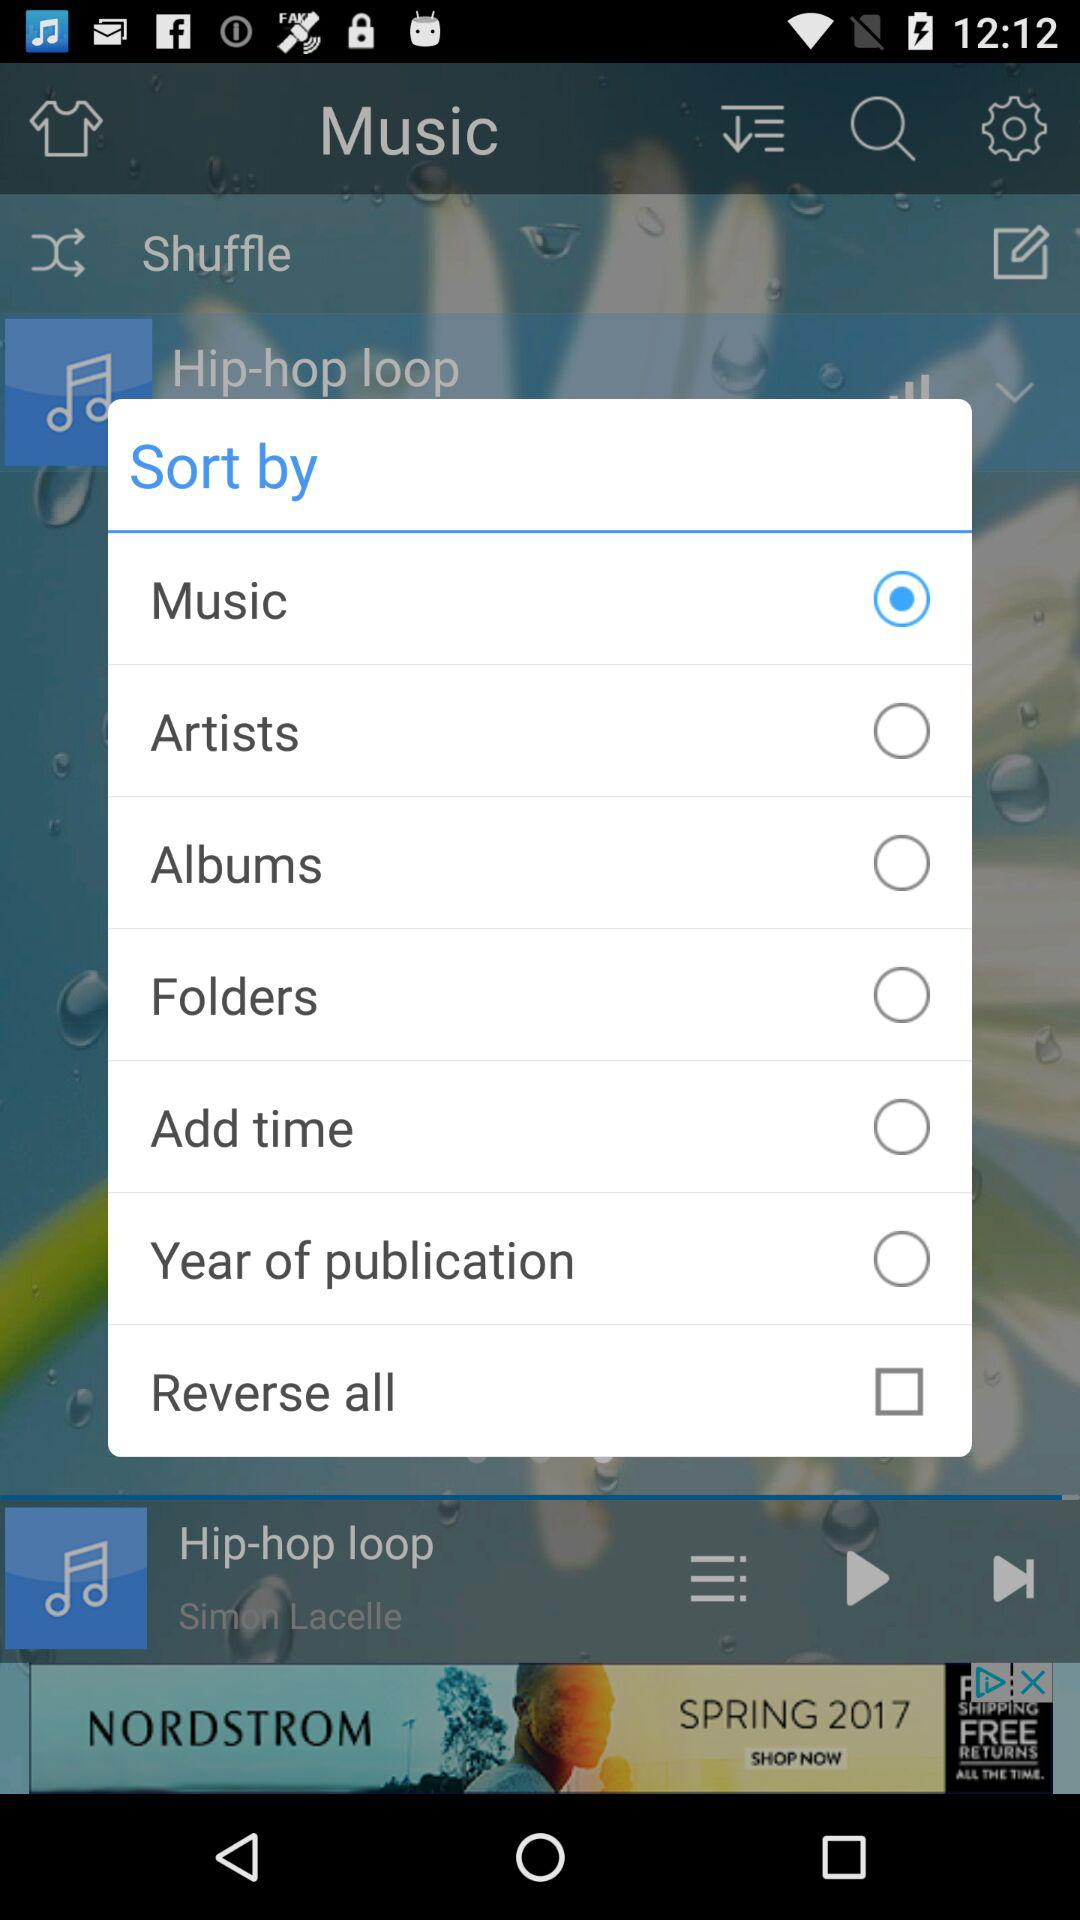What options are there for sorting the list? The options are "Music", "Artists", "Albums", "Folders", "Add time", "Year of publication" and "Reverse all". 